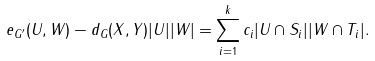<formula> <loc_0><loc_0><loc_500><loc_500>e _ { G ^ { \prime } } ( U , W ) - d _ { G } ( X , Y ) | U | | W | = \sum _ { i = 1 } ^ { k } c _ { i } | U \cap S _ { i } | | W \cap T _ { i } | .</formula> 